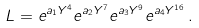<formula> <loc_0><loc_0><loc_500><loc_500>L = e ^ { a _ { 1 } Y ^ { 4 } } e ^ { a _ { 2 } Y ^ { 7 } } e ^ { a _ { 3 } Y ^ { 9 } } e ^ { a _ { 4 } Y ^ { 1 6 } } \, .</formula> 